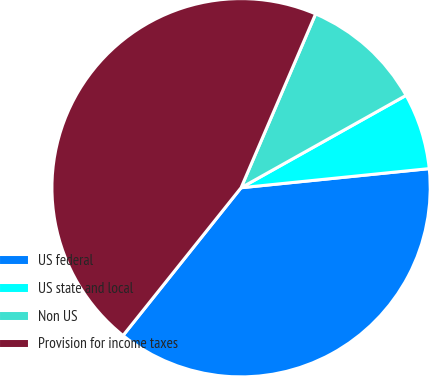<chart> <loc_0><loc_0><loc_500><loc_500><pie_chart><fcel>US federal<fcel>US state and local<fcel>Non US<fcel>Provision for income taxes<nl><fcel>37.34%<fcel>6.51%<fcel>10.43%<fcel>45.72%<nl></chart> 